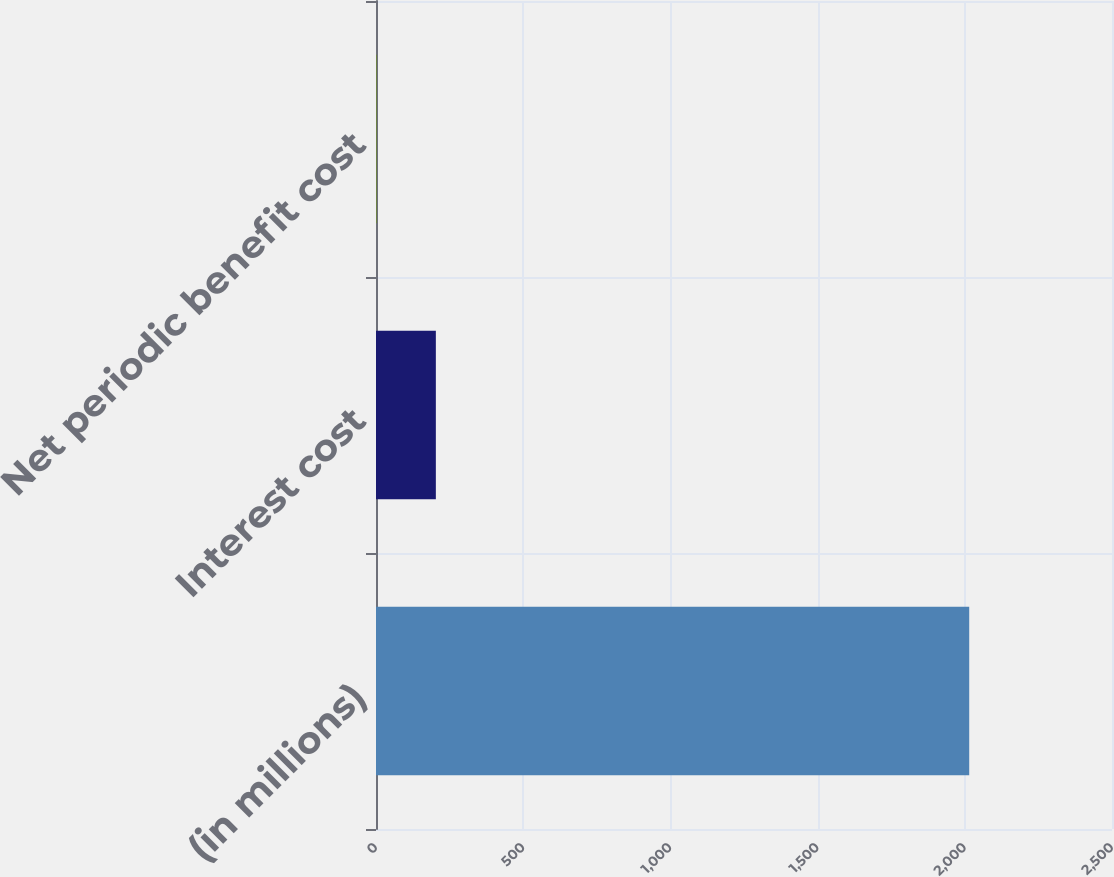Convert chart to OTSL. <chart><loc_0><loc_0><loc_500><loc_500><bar_chart><fcel>(in millions)<fcel>Interest cost<fcel>Net periodic benefit cost<nl><fcel>2015<fcel>203.3<fcel>2<nl></chart> 